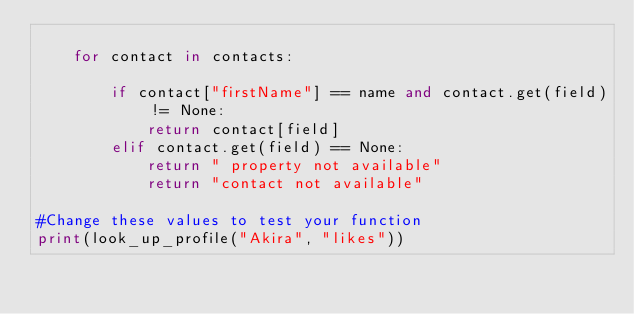<code> <loc_0><loc_0><loc_500><loc_500><_Python_>    
    for contact in contacts:
        
        if contact["firstName"] == name and contact.get(field) != None:
            return contact[field]
        elif contact.get(field) == None:
            return " property not available"
            return "contact not available"

#Change these values to test your function
print(look_up_profile("Akira", "likes"))</code> 